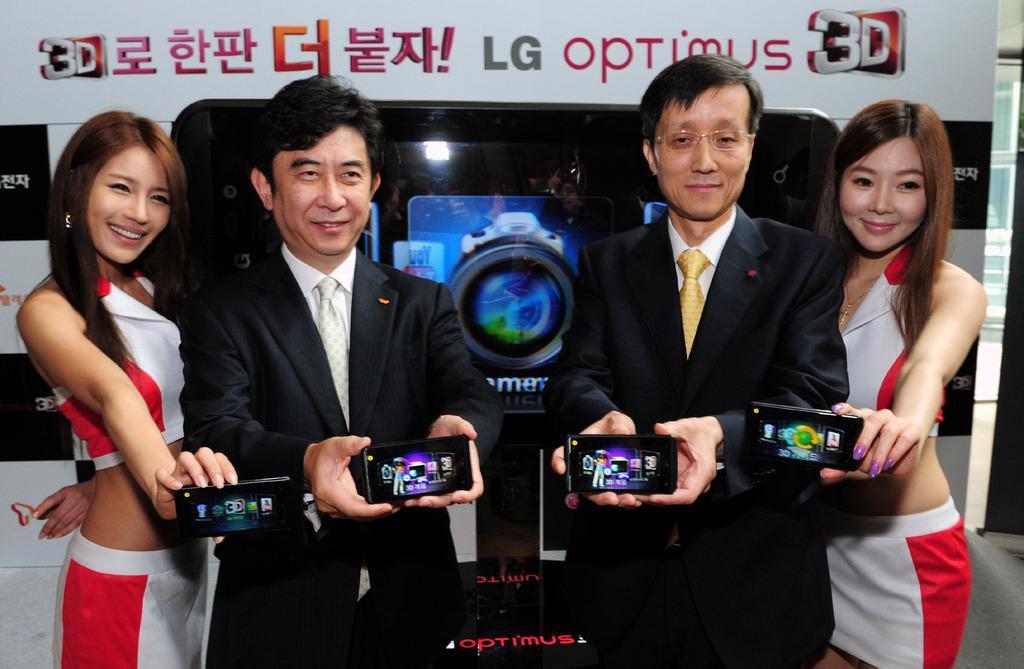In one or two sentences, can you explain what this image depicts? In this image i can see 2 men wearing white shirts and black blazers holding cell phones in their hands, and i can see 2 women standing and holding cell phones in their hands. In the background i can see a huge banner and a prototype of cell phone. 